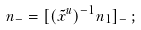<formula> <loc_0><loc_0><loc_500><loc_500>n _ { - } = [ ( \tilde { x } ^ { u } ) ^ { - 1 } n _ { 1 } ] _ { - } \, ;</formula> 